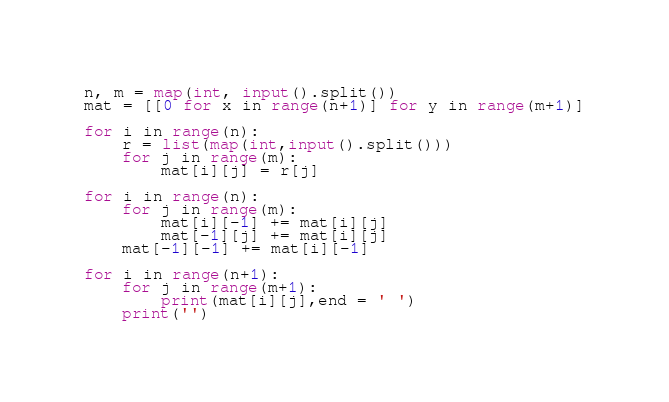Convert code to text. <code><loc_0><loc_0><loc_500><loc_500><_Python_>n, m = map(int, input().split())
mat = [[0 for x in range(n+1)] for y in range(m+1)]

for i in range(n):
    r = list(map(int,input().split()))
    for j in range(m):
        mat[i][j] = r[j]

for i in range(n):
    for j in range(m):
        mat[i][-1] += mat[i][j]
        mat[-1][j] += mat[i][j]
    mat[-1][-1] += mat[i][-1]
        
for i in range(n+1):
    for j in range(m+1):
        print(mat[i][j],end = ' ')
    print('')


</code> 